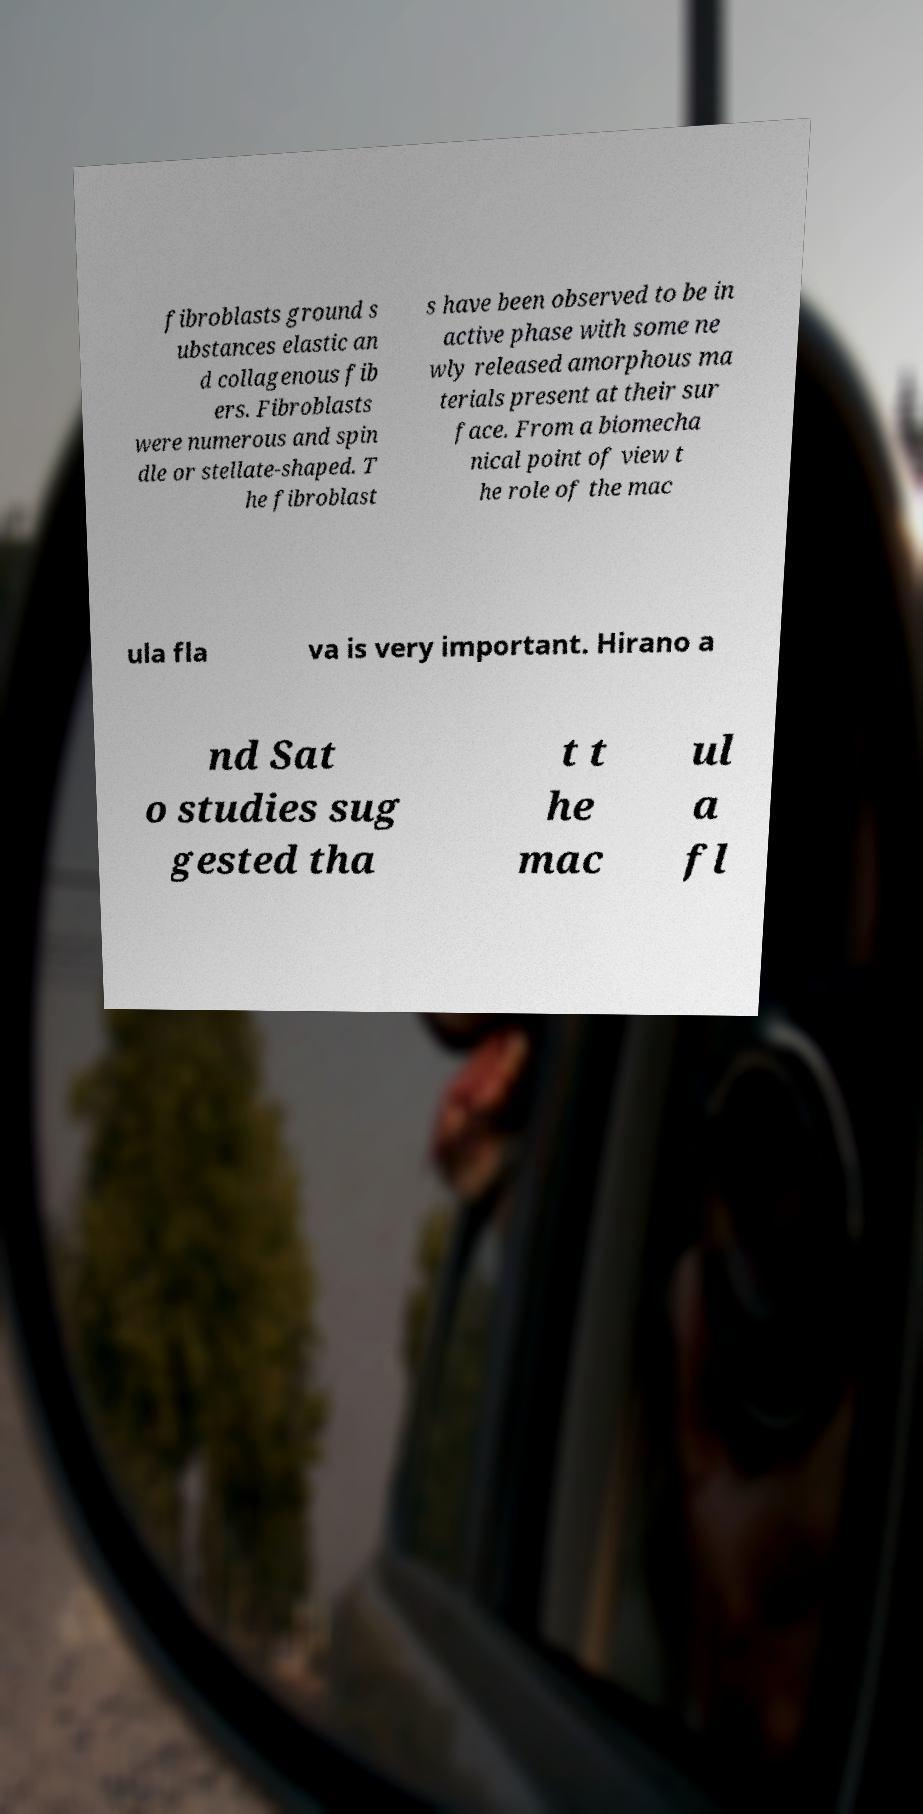There's text embedded in this image that I need extracted. Can you transcribe it verbatim? fibroblasts ground s ubstances elastic an d collagenous fib ers. Fibroblasts were numerous and spin dle or stellate-shaped. T he fibroblast s have been observed to be in active phase with some ne wly released amorphous ma terials present at their sur face. From a biomecha nical point of view t he role of the mac ula fla va is very important. Hirano a nd Sat o studies sug gested tha t t he mac ul a fl 